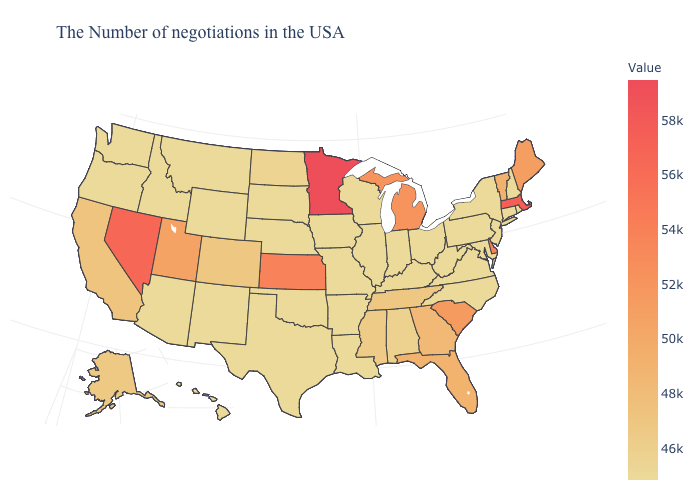Among the states that border Maine , which have the lowest value?
Short answer required. New Hampshire. Does Alabama have the highest value in the South?
Concise answer only. No. Does Arizona have a lower value than Florida?
Answer briefly. Yes. Among the states that border Indiana , which have the lowest value?
Short answer required. Ohio, Illinois. 